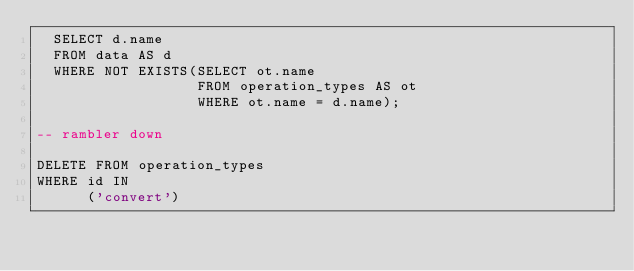<code> <loc_0><loc_0><loc_500><loc_500><_SQL_>  SELECT d.name
  FROM data AS d
  WHERE NOT EXISTS(SELECT ot.name
                   FROM operation_types AS ot
                   WHERE ot.name = d.name);

-- rambler down

DELETE FROM operation_types
WHERE id IN
      ('convert')
</code> 